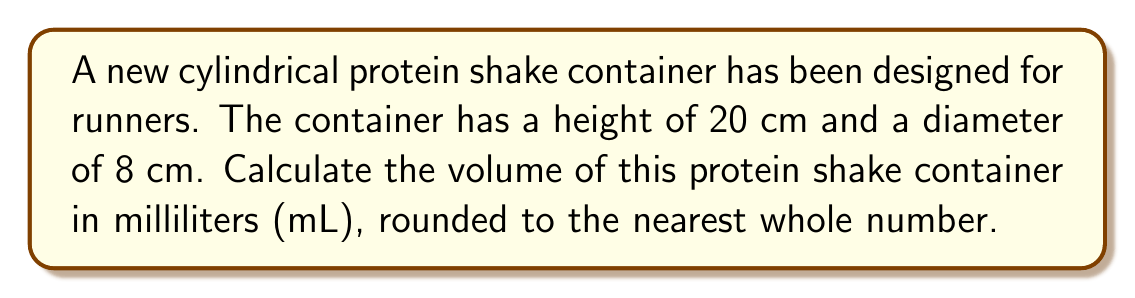Give your solution to this math problem. To find the volume of a cylindrical container, we need to use the formula for the volume of a cylinder:

$$V = \pi r^2 h$$

Where:
$V$ = volume
$r$ = radius of the base
$h$ = height of the cylinder

Given:
- Height (h) = 20 cm
- Diameter = 8 cm

Step 1: Calculate the radius
The radius is half the diameter:
$r = \frac{8}{2} = 4$ cm

Step 2: Apply the volume formula
$$V = \pi (4\text{ cm})^2 (20\text{ cm})$$

Step 3: Calculate the volume
$$V = \pi (16\text{ cm}^2) (20\text{ cm})$$
$$V = 320\pi\text{ cm}^3$$

Step 4: Use 3.14159 for π and calculate
$$V \approx 320 \times 3.14159\text{ cm}^3$$
$$V \approx 1005.3088\text{ cm}^3$$

Step 5: Convert cm³ to mL (1 cm³ = 1 mL)
$$V \approx 1005.3088\text{ mL}$$

Step 6: Round to the nearest whole number
$$V \approx 1005\text{ mL}$$
Answer: 1005 mL 